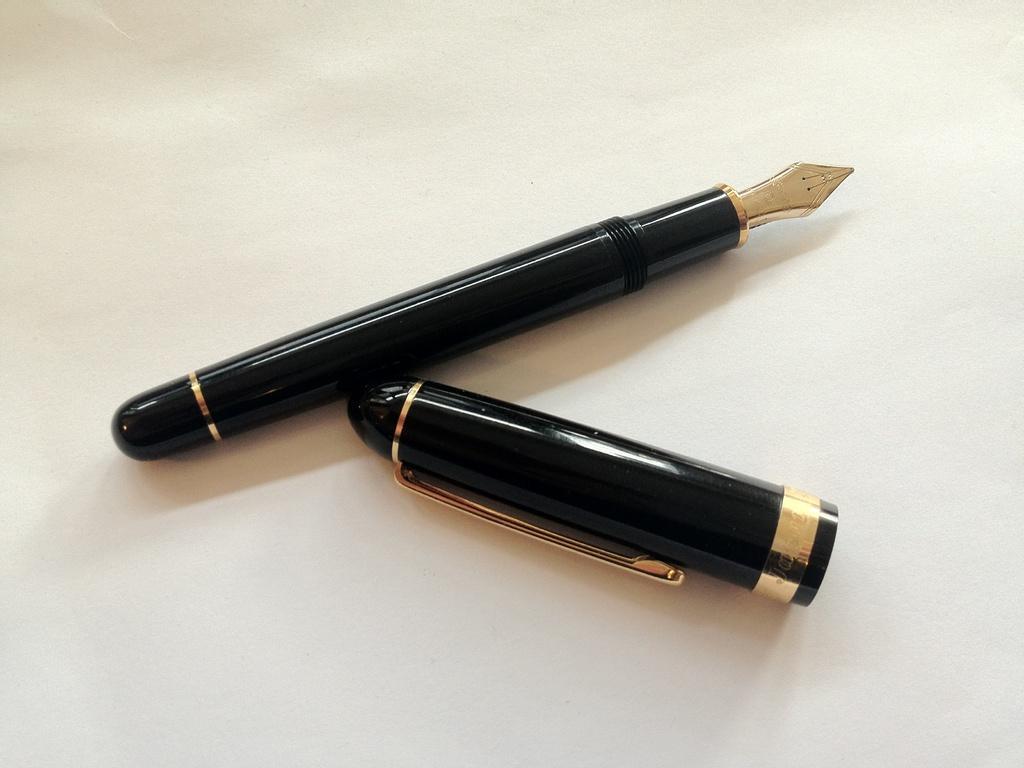Could you give a brief overview of what you see in this image? In the picture there is an ink pen, the cap of the pen is removed and kept beside the pen. 